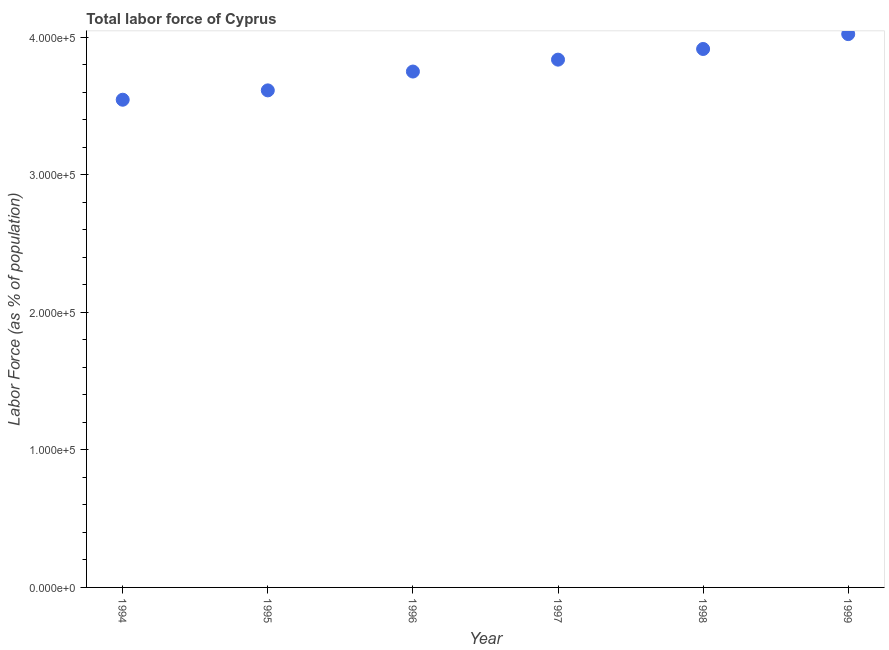What is the total labor force in 1999?
Make the answer very short. 4.02e+05. Across all years, what is the maximum total labor force?
Provide a succinct answer. 4.02e+05. Across all years, what is the minimum total labor force?
Provide a short and direct response. 3.55e+05. What is the sum of the total labor force?
Your answer should be very brief. 2.27e+06. What is the difference between the total labor force in 1998 and 1999?
Make the answer very short. -1.08e+04. What is the average total labor force per year?
Your answer should be compact. 3.78e+05. What is the median total labor force?
Offer a very short reply. 3.80e+05. What is the ratio of the total labor force in 1994 to that in 1995?
Your answer should be very brief. 0.98. What is the difference between the highest and the second highest total labor force?
Your response must be concise. 1.08e+04. Is the sum of the total labor force in 1995 and 1998 greater than the maximum total labor force across all years?
Give a very brief answer. Yes. What is the difference between the highest and the lowest total labor force?
Provide a short and direct response. 4.77e+04. In how many years, is the total labor force greater than the average total labor force taken over all years?
Ensure brevity in your answer.  3. How many dotlines are there?
Offer a very short reply. 1. What is the difference between two consecutive major ticks on the Y-axis?
Your answer should be very brief. 1.00e+05. Are the values on the major ticks of Y-axis written in scientific E-notation?
Your answer should be very brief. Yes. Does the graph contain any zero values?
Offer a terse response. No. Does the graph contain grids?
Offer a very short reply. No. What is the title of the graph?
Offer a very short reply. Total labor force of Cyprus. What is the label or title of the X-axis?
Your response must be concise. Year. What is the label or title of the Y-axis?
Ensure brevity in your answer.  Labor Force (as % of population). What is the Labor Force (as % of population) in 1994?
Your answer should be compact. 3.55e+05. What is the Labor Force (as % of population) in 1995?
Offer a very short reply. 3.62e+05. What is the Labor Force (as % of population) in 1996?
Provide a short and direct response. 3.75e+05. What is the Labor Force (as % of population) in 1997?
Offer a very short reply. 3.84e+05. What is the Labor Force (as % of population) in 1998?
Your answer should be very brief. 3.92e+05. What is the Labor Force (as % of population) in 1999?
Give a very brief answer. 4.02e+05. What is the difference between the Labor Force (as % of population) in 1994 and 1995?
Your response must be concise. -6803. What is the difference between the Labor Force (as % of population) in 1994 and 1996?
Provide a short and direct response. -2.05e+04. What is the difference between the Labor Force (as % of population) in 1994 and 1997?
Give a very brief answer. -2.92e+04. What is the difference between the Labor Force (as % of population) in 1994 and 1998?
Provide a short and direct response. -3.69e+04. What is the difference between the Labor Force (as % of population) in 1994 and 1999?
Provide a succinct answer. -4.77e+04. What is the difference between the Labor Force (as % of population) in 1995 and 1996?
Your answer should be compact. -1.37e+04. What is the difference between the Labor Force (as % of population) in 1995 and 1997?
Your answer should be compact. -2.24e+04. What is the difference between the Labor Force (as % of population) in 1995 and 1998?
Give a very brief answer. -3.01e+04. What is the difference between the Labor Force (as % of population) in 1995 and 1999?
Ensure brevity in your answer.  -4.09e+04. What is the difference between the Labor Force (as % of population) in 1996 and 1997?
Make the answer very short. -8655. What is the difference between the Labor Force (as % of population) in 1996 and 1998?
Your answer should be compact. -1.64e+04. What is the difference between the Labor Force (as % of population) in 1996 and 1999?
Your answer should be very brief. -2.72e+04. What is the difference between the Labor Force (as % of population) in 1997 and 1998?
Offer a very short reply. -7755. What is the difference between the Labor Force (as % of population) in 1997 and 1999?
Ensure brevity in your answer.  -1.86e+04. What is the difference between the Labor Force (as % of population) in 1998 and 1999?
Offer a very short reply. -1.08e+04. What is the ratio of the Labor Force (as % of population) in 1994 to that in 1995?
Offer a very short reply. 0.98. What is the ratio of the Labor Force (as % of population) in 1994 to that in 1996?
Provide a short and direct response. 0.94. What is the ratio of the Labor Force (as % of population) in 1994 to that in 1997?
Give a very brief answer. 0.92. What is the ratio of the Labor Force (as % of population) in 1994 to that in 1998?
Offer a very short reply. 0.91. What is the ratio of the Labor Force (as % of population) in 1994 to that in 1999?
Offer a terse response. 0.88. What is the ratio of the Labor Force (as % of population) in 1995 to that in 1996?
Ensure brevity in your answer.  0.96. What is the ratio of the Labor Force (as % of population) in 1995 to that in 1997?
Keep it short and to the point. 0.94. What is the ratio of the Labor Force (as % of population) in 1995 to that in 1998?
Your answer should be compact. 0.92. What is the ratio of the Labor Force (as % of population) in 1995 to that in 1999?
Keep it short and to the point. 0.9. What is the ratio of the Labor Force (as % of population) in 1996 to that in 1997?
Your answer should be compact. 0.98. What is the ratio of the Labor Force (as % of population) in 1996 to that in 1998?
Keep it short and to the point. 0.96. What is the ratio of the Labor Force (as % of population) in 1996 to that in 1999?
Offer a very short reply. 0.93. What is the ratio of the Labor Force (as % of population) in 1997 to that in 1998?
Provide a succinct answer. 0.98. What is the ratio of the Labor Force (as % of population) in 1997 to that in 1999?
Give a very brief answer. 0.95. What is the ratio of the Labor Force (as % of population) in 1998 to that in 1999?
Offer a terse response. 0.97. 